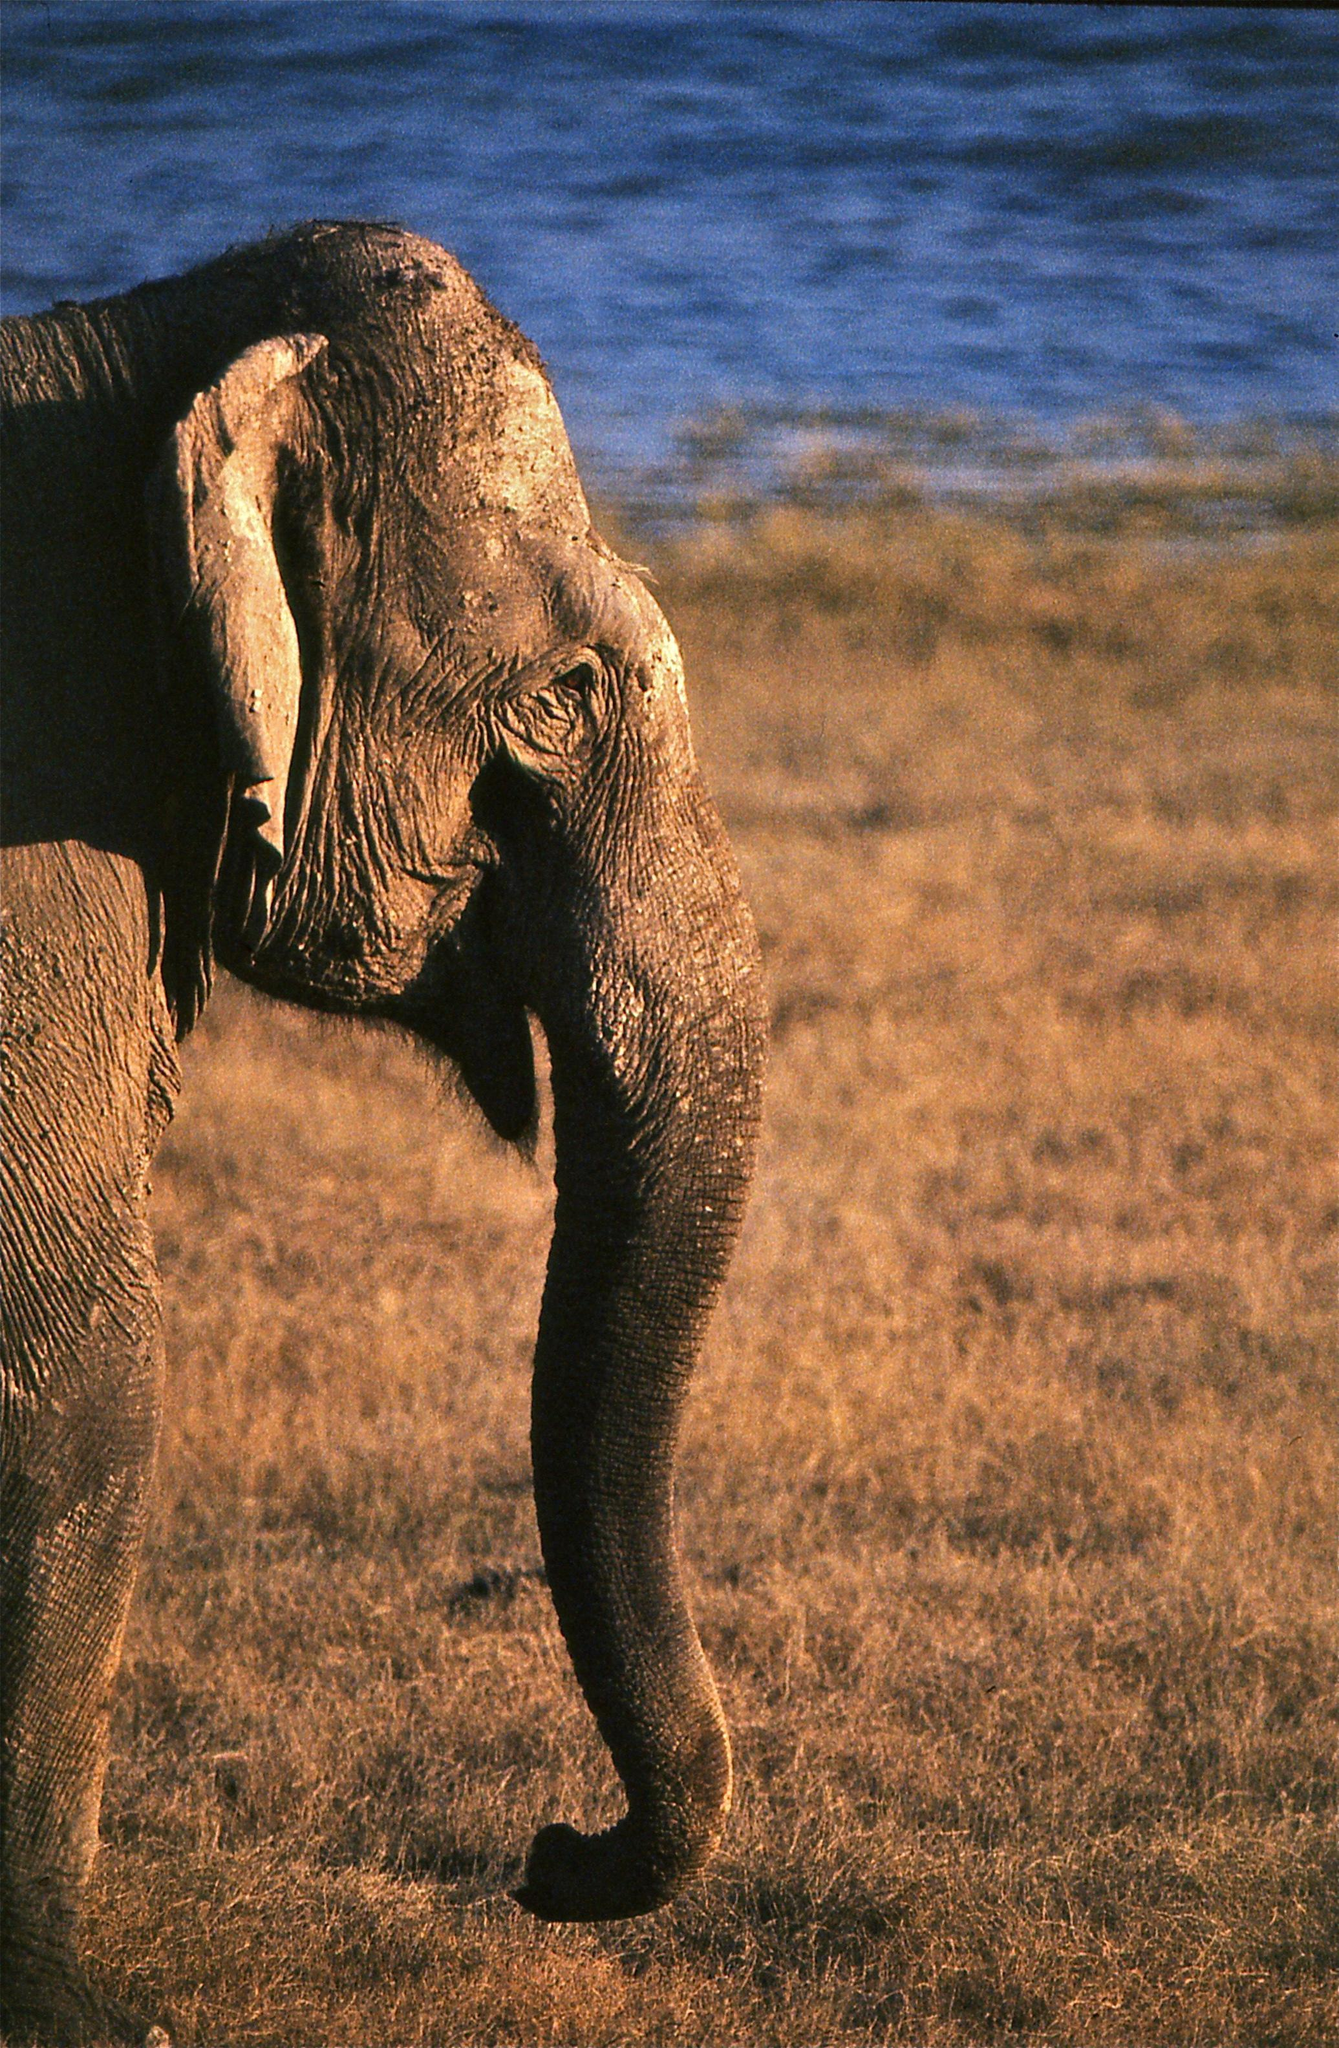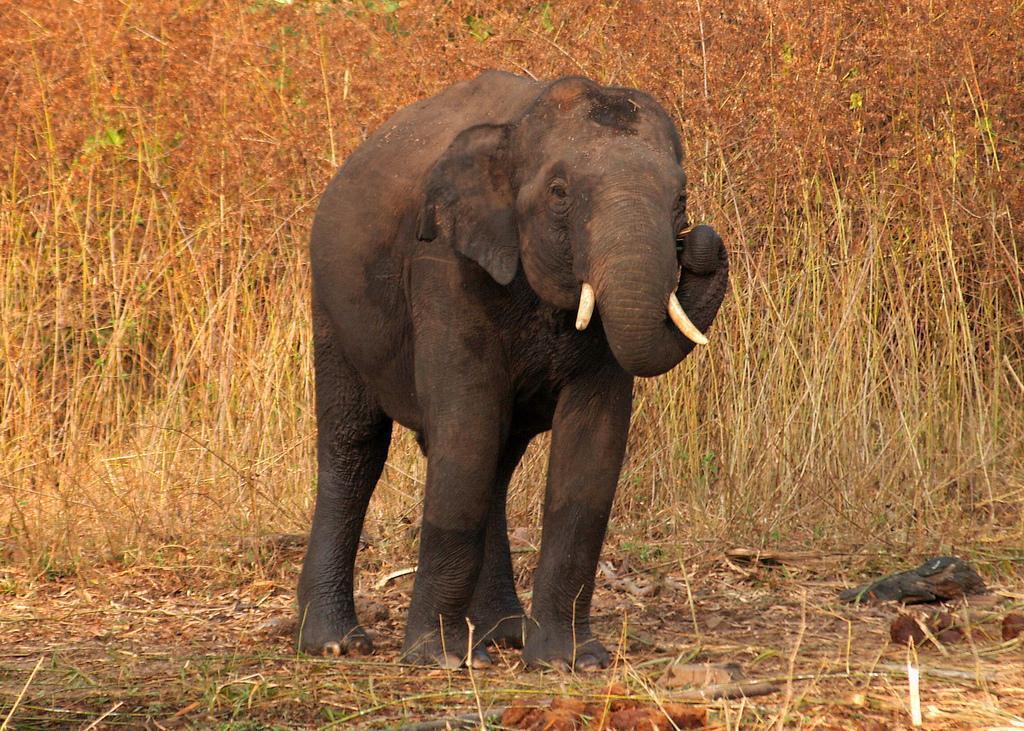The first image is the image on the left, the second image is the image on the right. Considering the images on both sides, is "The elephant in the left image is near the water." valid? Answer yes or no. Yes. The first image is the image on the left, the second image is the image on the right. Considering the images on both sides, is "An elephant with tusks has the end of his trunk curled and raised up." valid? Answer yes or no. Yes. 